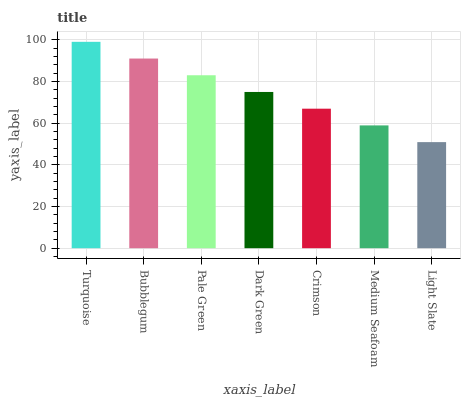Is Turquoise the maximum?
Answer yes or no. Yes. Is Bubblegum the minimum?
Answer yes or no. No. Is Bubblegum the maximum?
Answer yes or no. No. Is Turquoise greater than Bubblegum?
Answer yes or no. Yes. Is Bubblegum less than Turquoise?
Answer yes or no. Yes. Is Bubblegum greater than Turquoise?
Answer yes or no. No. Is Turquoise less than Bubblegum?
Answer yes or no. No. Is Dark Green the high median?
Answer yes or no. Yes. Is Dark Green the low median?
Answer yes or no. Yes. Is Pale Green the high median?
Answer yes or no. No. Is Turquoise the low median?
Answer yes or no. No. 